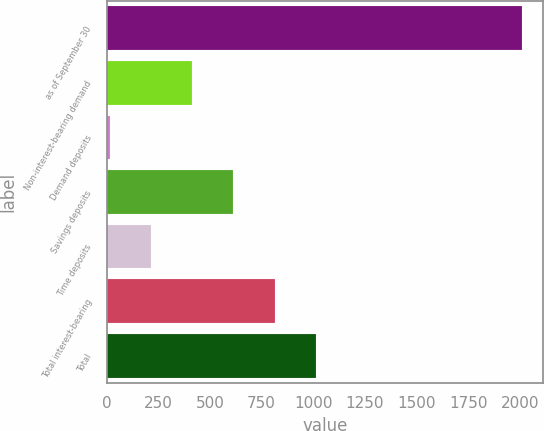<chart> <loc_0><loc_0><loc_500><loc_500><bar_chart><fcel>as of September 30<fcel>Non-interest-bearing demand<fcel>Demand deposits<fcel>Savings deposits<fcel>Time deposits<fcel>Total interest-bearing<fcel>Total<nl><fcel>2012<fcel>412.56<fcel>12.7<fcel>612.49<fcel>212.63<fcel>812.42<fcel>1012.35<nl></chart> 